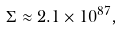Convert formula to latex. <formula><loc_0><loc_0><loc_500><loc_500>\Sigma \approx 2 . 1 \times 1 0 ^ { 8 7 } ,</formula> 